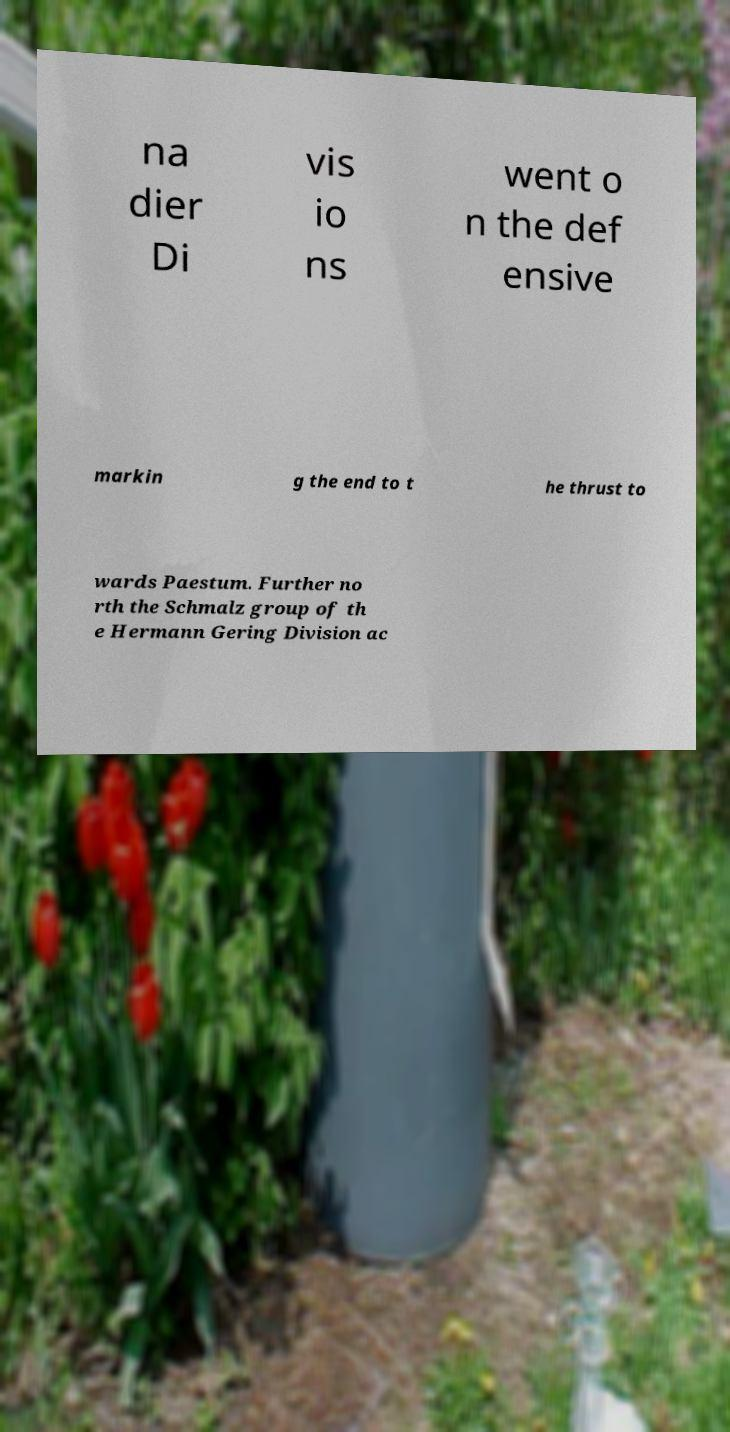Could you extract and type out the text from this image? na dier Di vis io ns went o n the def ensive markin g the end to t he thrust to wards Paestum. Further no rth the Schmalz group of th e Hermann Gering Division ac 